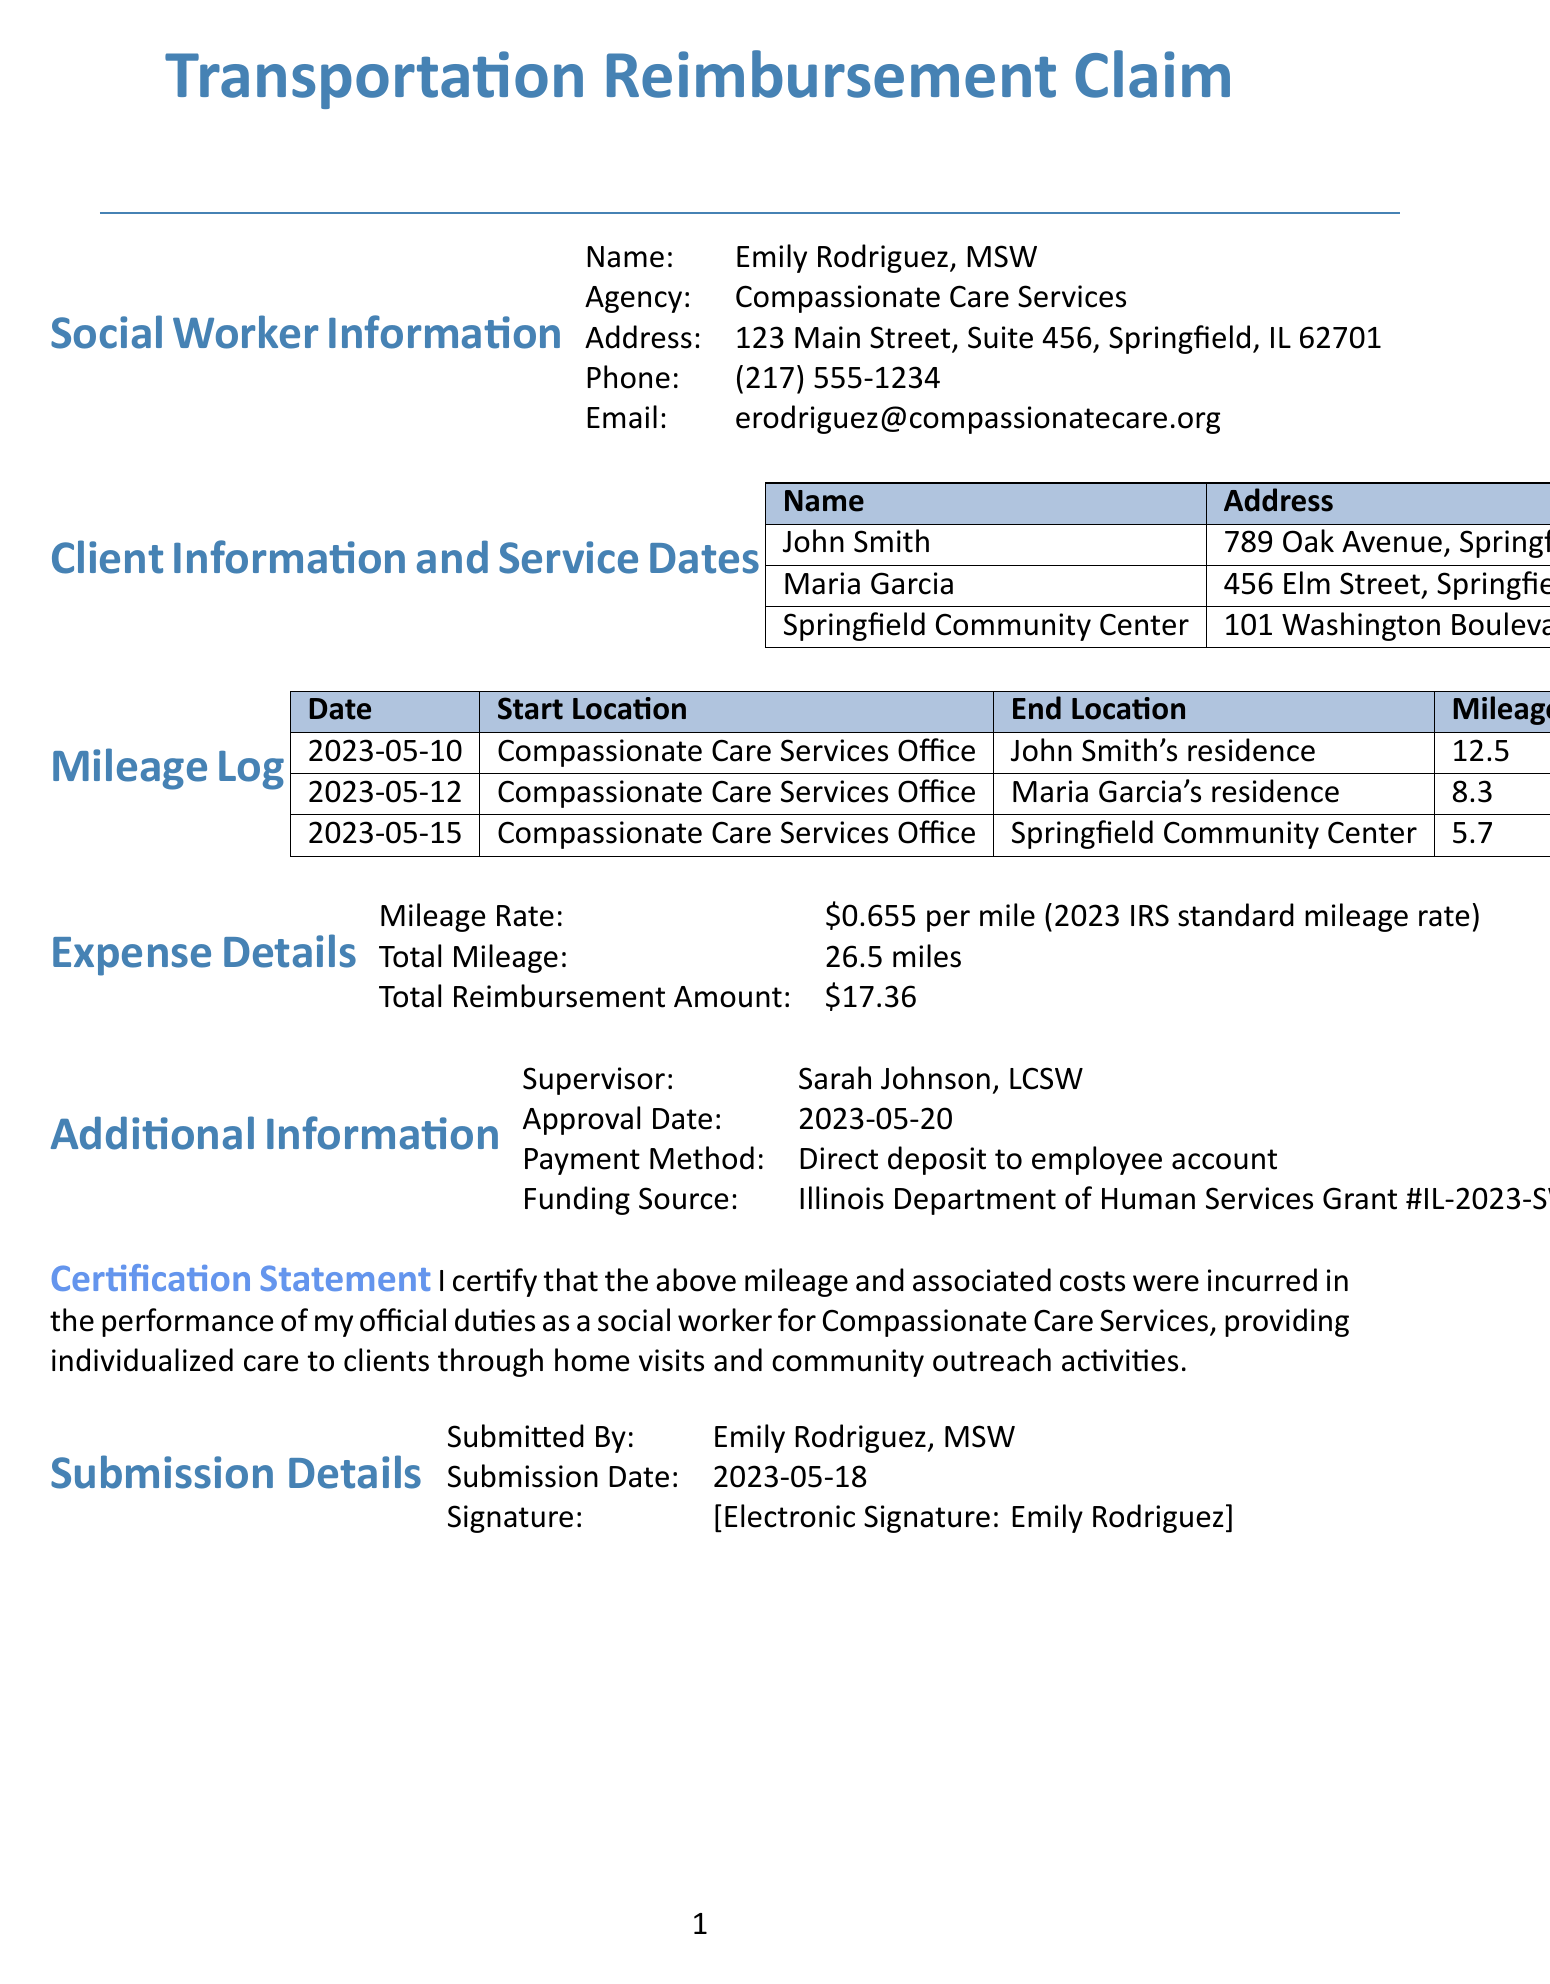what is the name of the social worker? The document provides the name of the social worker in the header section.
Answer: Emily Rodriguez, MSW what is the address of the agency? The agency's address is listed under the social worker information.
Answer: 123 Main Street, Suite 456, Springfield, IL 62701 how many miles were claimed for reimbursement? The total mileage is listed in the expense details section of the document.
Answer: 26.5 what was the purpose of the visit on May 10, 2023? The purpose of each visit is detailed in the mileage log section by date.
Answer: Home visit for mental health assessment who is the supervisor mentioned in the document? The name of the supervisor is provided under the additional information section.
Answer: Sarah Johnson, LCSW what is the approval date of this invoice? The approval date can be found in the additional information section.
Answer: 2023-05-20 what is the total reimbursement amount? The total reimbursement amount is specified in the expense details.
Answer: $17.36 how was the payment method described? The payment method is included in the additional information section.
Answer: Direct deposit to employee account what is the funding source for the services? The funding source is mentioned in the additional information section.
Answer: Illinois Department of Human Services Grant #IL-2023-SW-001 